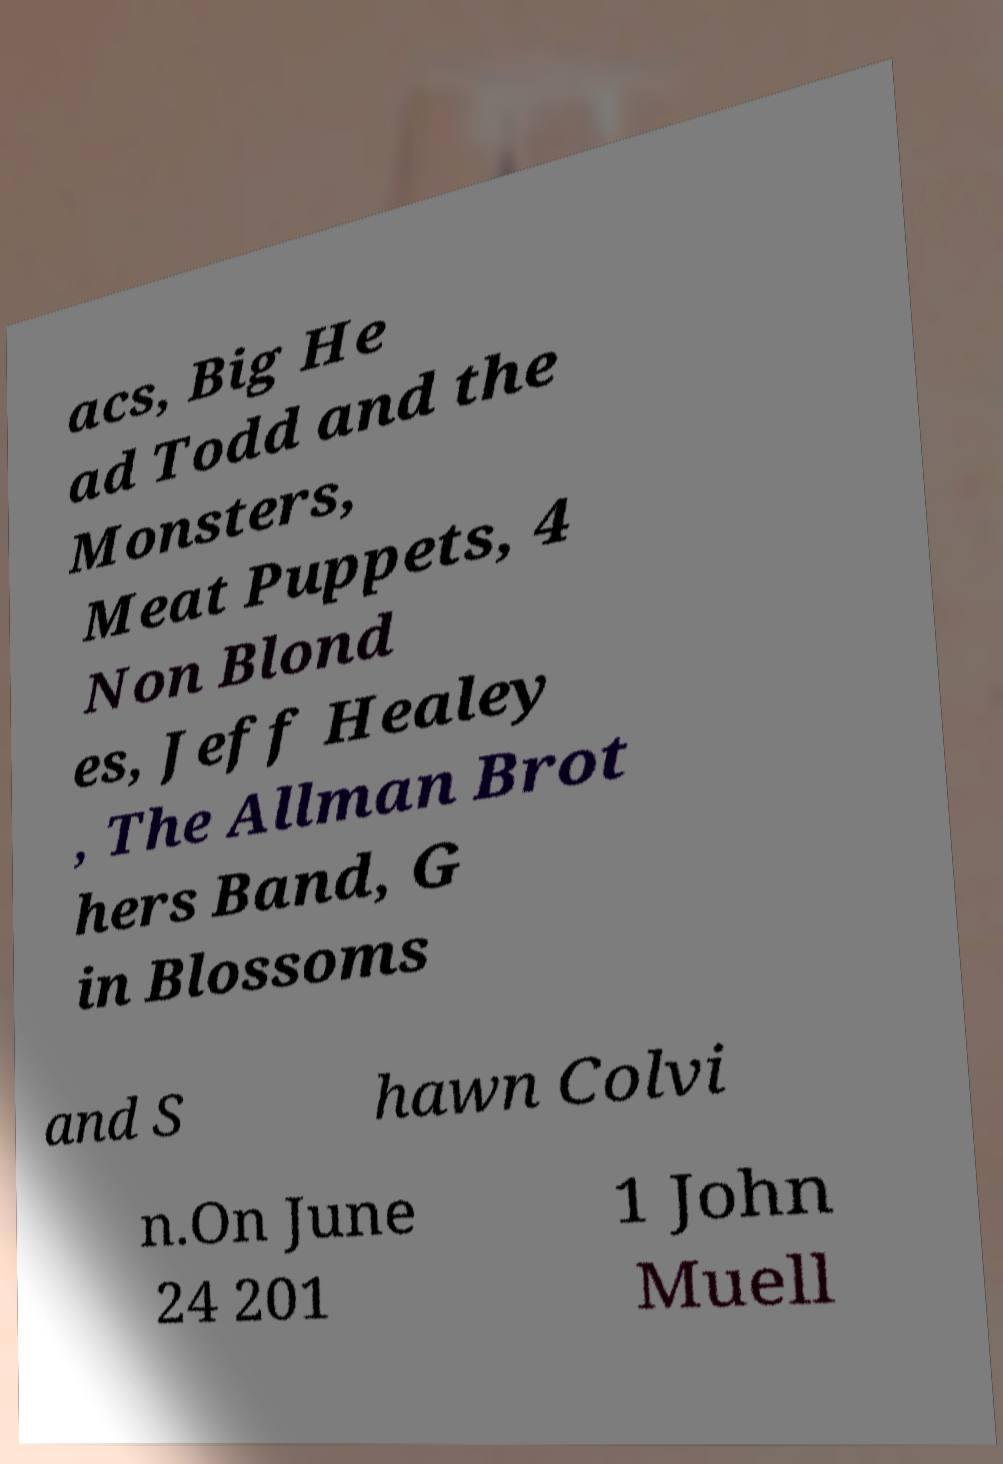Could you extract and type out the text from this image? acs, Big He ad Todd and the Monsters, Meat Puppets, 4 Non Blond es, Jeff Healey , The Allman Brot hers Band, G in Blossoms and S hawn Colvi n.On June 24 201 1 John Muell 